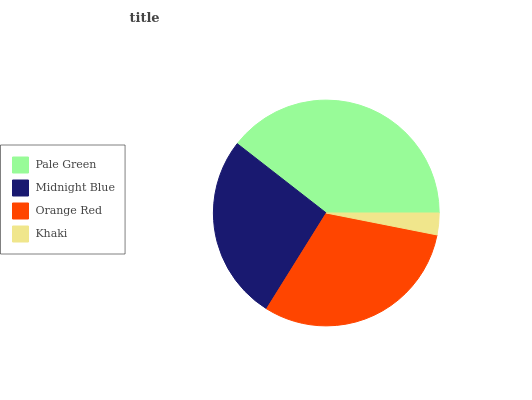Is Khaki the minimum?
Answer yes or no. Yes. Is Pale Green the maximum?
Answer yes or no. Yes. Is Midnight Blue the minimum?
Answer yes or no. No. Is Midnight Blue the maximum?
Answer yes or no. No. Is Pale Green greater than Midnight Blue?
Answer yes or no. Yes. Is Midnight Blue less than Pale Green?
Answer yes or no. Yes. Is Midnight Blue greater than Pale Green?
Answer yes or no. No. Is Pale Green less than Midnight Blue?
Answer yes or no. No. Is Orange Red the high median?
Answer yes or no. Yes. Is Midnight Blue the low median?
Answer yes or no. Yes. Is Midnight Blue the high median?
Answer yes or no. No. Is Orange Red the low median?
Answer yes or no. No. 